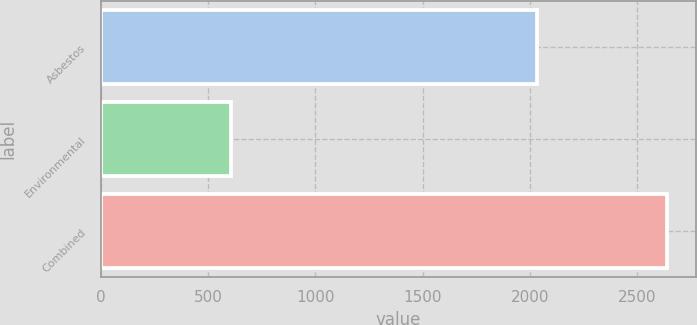<chart> <loc_0><loc_0><loc_500><loc_500><bar_chart><fcel>Asbestos<fcel>Environmental<fcel>Combined<nl><fcel>2033<fcel>606<fcel>2639<nl></chart> 